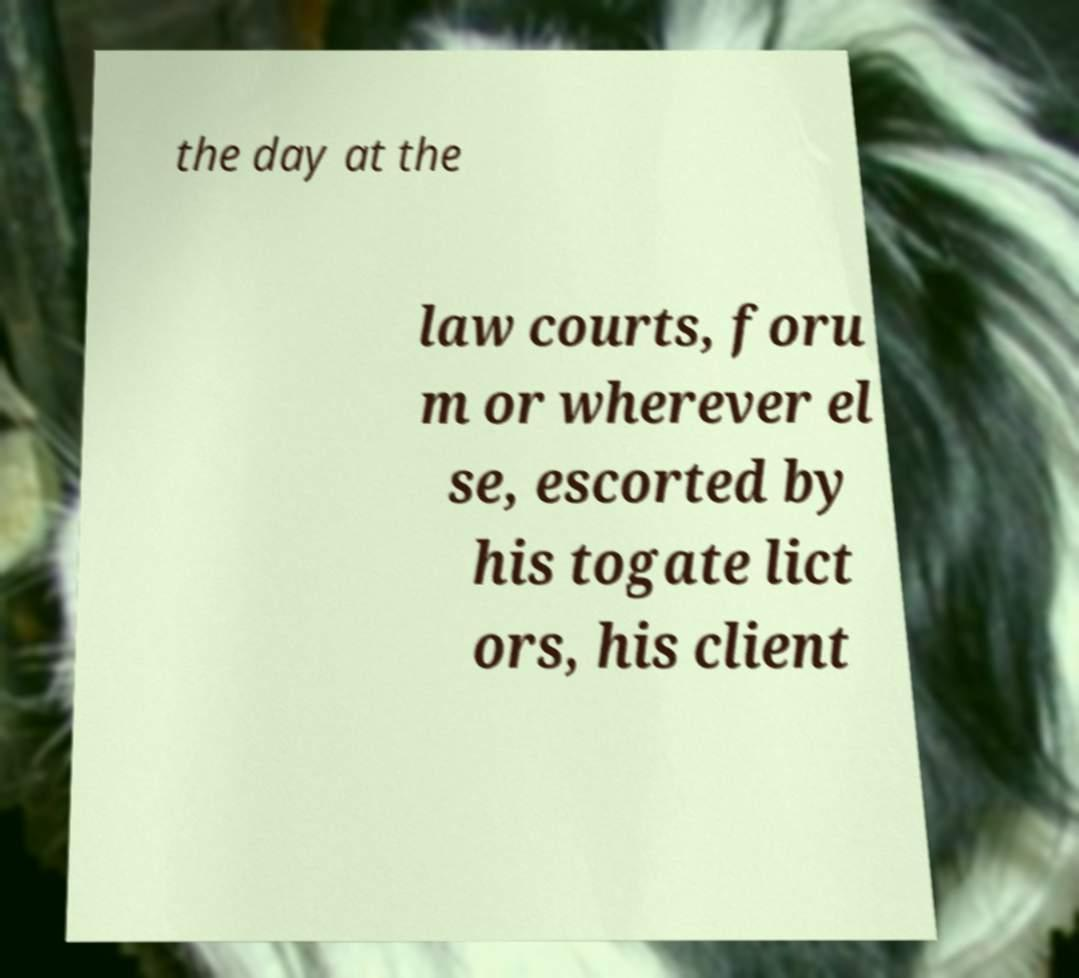Can you read and provide the text displayed in the image?This photo seems to have some interesting text. Can you extract and type it out for me? the day at the law courts, foru m or wherever el se, escorted by his togate lict ors, his client 